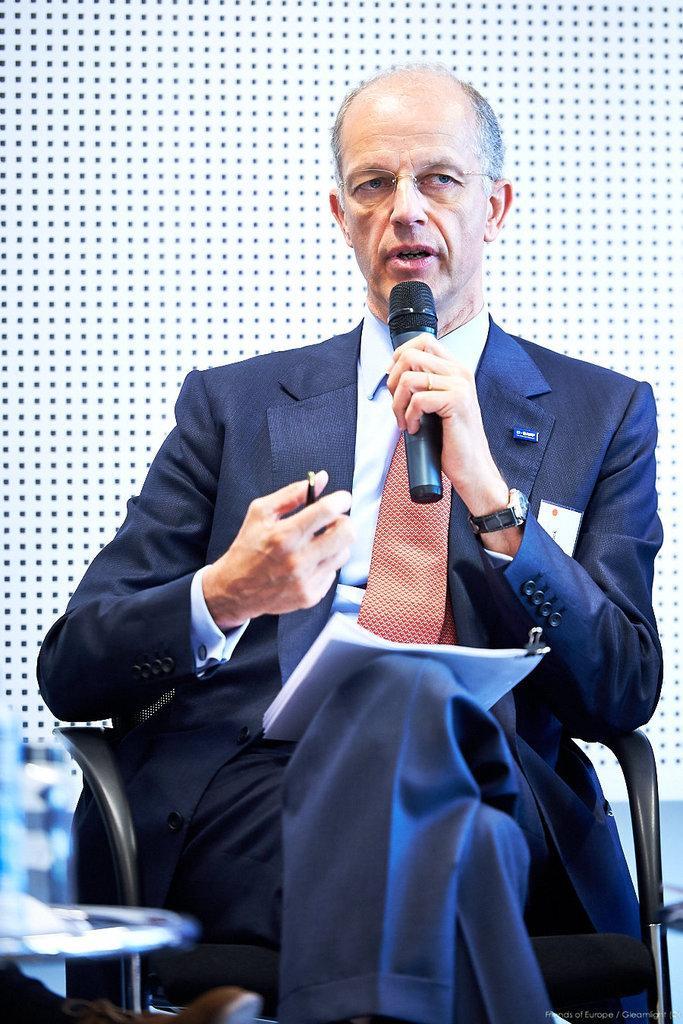In one or two sentences, can you explain what this image depicts? A person in blue suit is holding a mic and talking. He is also wearing a watch and spectacles. He is having a paper and pen. He is sitting on a chair. 